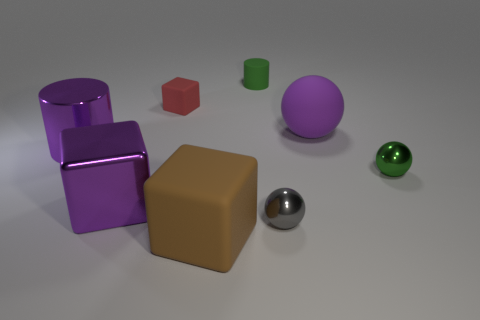Is there any indication of the size of these objects? There is no clear reference object to accurately assess the size of these objects, but the spatial arrangement and shadows give a relative sense of dimension, suggesting they could be sized similar to common household items.  What purpose could these objects serve in a practical context? In a practical context, these objects could be used for educational purposes, such as in a physics classroom to demonstrate properties of light reflection and refraction, or as props in a visual arts course to teach about color and composition. 